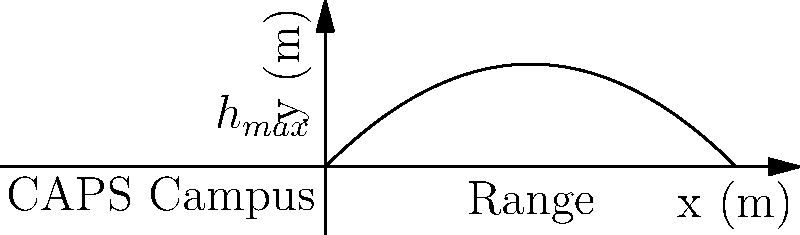During the annual CAPS Physics Olympics, a projectile is launched from the campus ground with an initial velocity of 20 m/s at an angle of 45° above the horizontal. Neglecting air resistance, what is the maximum height reached by the projectile? To find the maximum height, we can follow these steps:

1) The vertical component of the initial velocity is:
   $v_{0y} = v_0 \sin \theta = 20 \sin 45° = 20 \cdot \frac{\sqrt{2}}{2} \approx 14.14$ m/s

2) The time to reach the maximum height is when the vertical velocity becomes zero:
   $0 = v_{0y} - gt$
   $t = \frac{v_{0y}}{g} = \frac{14.14}{9.8} \approx 1.44$ s

3) The maximum height can be calculated using the equation:
   $h_{max} = v_{0y}t - \frac{1}{2}gt^2$

4) Substituting the values:
   $h_{max} = 14.14 \cdot 1.44 - \frac{1}{2} \cdot 9.8 \cdot 1.44^2$
   $h_{max} = 20.36 - 10.18 = 10.18$ m

5) We can also use the energy conservation principle:
   $\frac{1}{2}mv_{0y}^2 = mgh_{max}$
   $h_{max} = \frac{v_{0y}^2}{2g} = \frac{14.14^2}{2 \cdot 9.8} \approx 10.18$ m

Therefore, the maximum height reached by the projectile is approximately 10.18 meters.
Answer: 10.18 m 